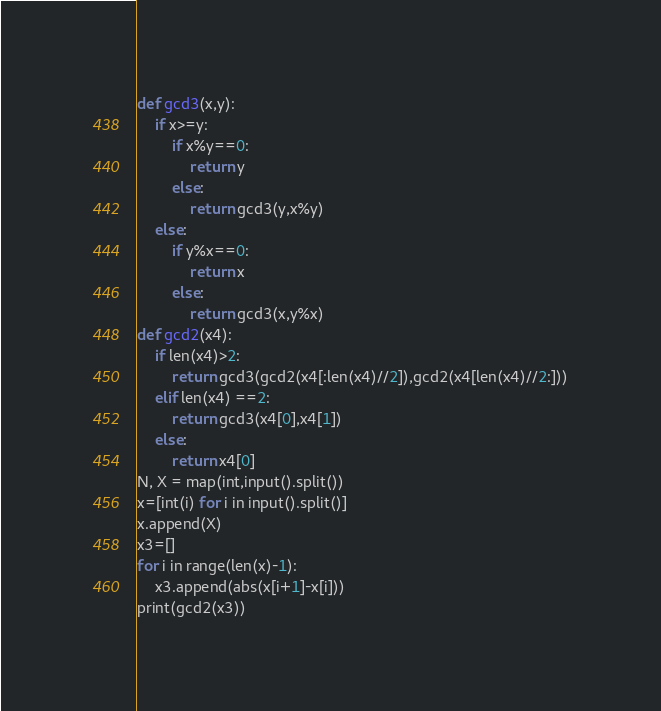<code> <loc_0><loc_0><loc_500><loc_500><_Python_>def gcd3(x,y):
    if x>=y:
        if x%y==0:
            return y
        else:
            return gcd3(y,x%y)
    else:
        if y%x==0:
            return x
        else:
            return gcd3(x,y%x)
def gcd2(x4):
    if len(x4)>2:
        return gcd3(gcd2(x4[:len(x4)//2]),gcd2(x4[len(x4)//2:]))
    elif len(x4) ==2:
        return gcd3(x4[0],x4[1])
    else:
        return x4[0]
N, X = map(int,input().split())
x=[int(i) for i in input().split()]
x.append(X)
x3=[]
for i in range(len(x)-1):
    x3.append(abs(x[i+1]-x[i]))
print(gcd2(x3))
</code> 